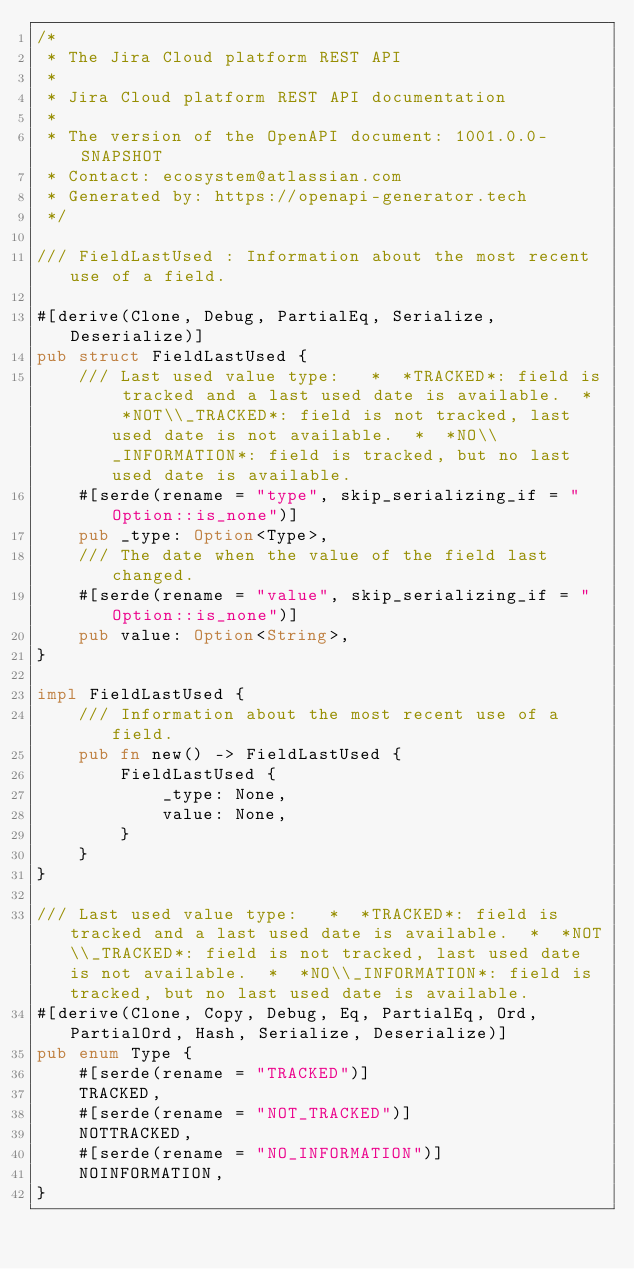<code> <loc_0><loc_0><loc_500><loc_500><_Rust_>/*
 * The Jira Cloud platform REST API
 *
 * Jira Cloud platform REST API documentation
 *
 * The version of the OpenAPI document: 1001.0.0-SNAPSHOT
 * Contact: ecosystem@atlassian.com
 * Generated by: https://openapi-generator.tech
 */

/// FieldLastUsed : Information about the most recent use of a field.

#[derive(Clone, Debug, PartialEq, Serialize, Deserialize)]
pub struct FieldLastUsed {
    /// Last used value type:   *  *TRACKED*: field is tracked and a last used date is available.  *  *NOT\\_TRACKED*: field is not tracked, last used date is not available.  *  *NO\\_INFORMATION*: field is tracked, but no last used date is available.
    #[serde(rename = "type", skip_serializing_if = "Option::is_none")]
    pub _type: Option<Type>,
    /// The date when the value of the field last changed.
    #[serde(rename = "value", skip_serializing_if = "Option::is_none")]
    pub value: Option<String>,
}

impl FieldLastUsed {
    /// Information about the most recent use of a field.
    pub fn new() -> FieldLastUsed {
        FieldLastUsed {
            _type: None,
            value: None,
        }
    }
}

/// Last used value type:   *  *TRACKED*: field is tracked and a last used date is available.  *  *NOT\\_TRACKED*: field is not tracked, last used date is not available.  *  *NO\\_INFORMATION*: field is tracked, but no last used date is available.
#[derive(Clone, Copy, Debug, Eq, PartialEq, Ord, PartialOrd, Hash, Serialize, Deserialize)]
pub enum Type {
    #[serde(rename = "TRACKED")]
    TRACKED,
    #[serde(rename = "NOT_TRACKED")]
    NOTTRACKED,
    #[serde(rename = "NO_INFORMATION")]
    NOINFORMATION,
}
</code> 